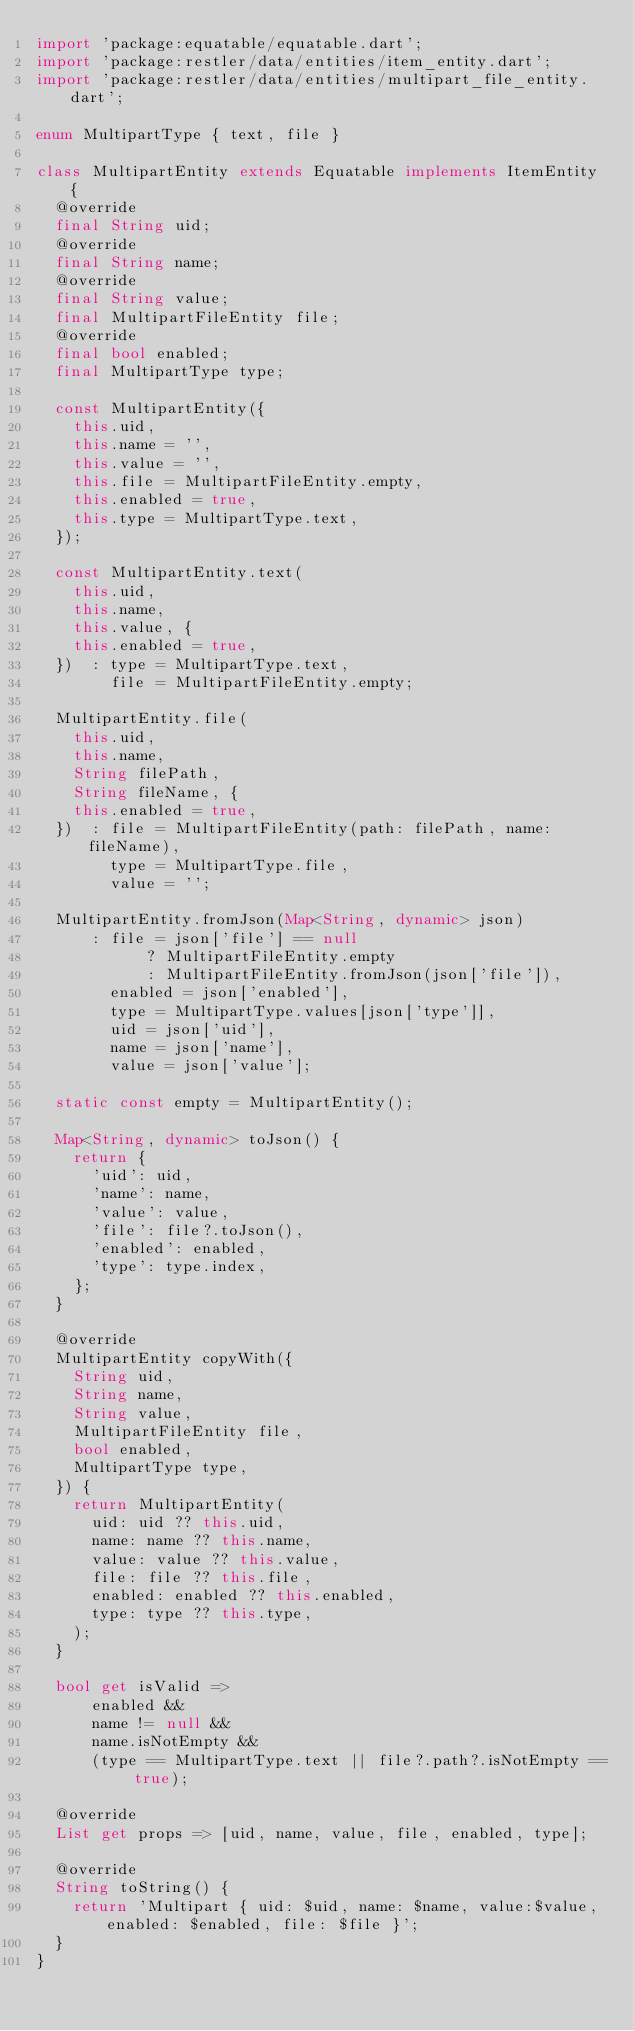<code> <loc_0><loc_0><loc_500><loc_500><_Dart_>import 'package:equatable/equatable.dart';
import 'package:restler/data/entities/item_entity.dart';
import 'package:restler/data/entities/multipart_file_entity.dart';

enum MultipartType { text, file }

class MultipartEntity extends Equatable implements ItemEntity {
  @override
  final String uid;
  @override
  final String name;
  @override
  final String value;
  final MultipartFileEntity file;
  @override
  final bool enabled;
  final MultipartType type;

  const MultipartEntity({
    this.uid,
    this.name = '',
    this.value = '',
    this.file = MultipartFileEntity.empty,
    this.enabled = true,
    this.type = MultipartType.text,
  });

  const MultipartEntity.text(
    this.uid,
    this.name,
    this.value, {
    this.enabled = true,
  })  : type = MultipartType.text,
        file = MultipartFileEntity.empty;

  MultipartEntity.file(
    this.uid,
    this.name,
    String filePath,
    String fileName, {
    this.enabled = true,
  })  : file = MultipartFileEntity(path: filePath, name: fileName),
        type = MultipartType.file,
        value = '';

  MultipartEntity.fromJson(Map<String, dynamic> json)
      : file = json['file'] == null
            ? MultipartFileEntity.empty
            : MultipartFileEntity.fromJson(json['file']),
        enabled = json['enabled'],
        type = MultipartType.values[json['type']],
        uid = json['uid'],
        name = json['name'],
        value = json['value'];

  static const empty = MultipartEntity();

  Map<String, dynamic> toJson() {
    return {
      'uid': uid,
      'name': name,
      'value': value,
      'file': file?.toJson(),
      'enabled': enabled,
      'type': type.index,
    };
  }

  @override
  MultipartEntity copyWith({
    String uid,
    String name,
    String value,
    MultipartFileEntity file,
    bool enabled,
    MultipartType type,
  }) {
    return MultipartEntity(
      uid: uid ?? this.uid,
      name: name ?? this.name,
      value: value ?? this.value,
      file: file ?? this.file,
      enabled: enabled ?? this.enabled,
      type: type ?? this.type,
    );
  }

  bool get isValid =>
      enabled &&
      name != null &&
      name.isNotEmpty &&
      (type == MultipartType.text || file?.path?.isNotEmpty == true);

  @override
  List get props => [uid, name, value, file, enabled, type];

  @override
  String toString() {
    return 'Multipart { uid: $uid, name: $name, value:$value, enabled: $enabled, file: $file }';
  }
}
</code> 